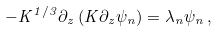Convert formula to latex. <formula><loc_0><loc_0><loc_500><loc_500>- K ^ { 1 / 3 } \partial _ { z } \left ( K \partial _ { z } \psi _ { n } \right ) = \lambda _ { n } \psi _ { n } \, ,</formula> 